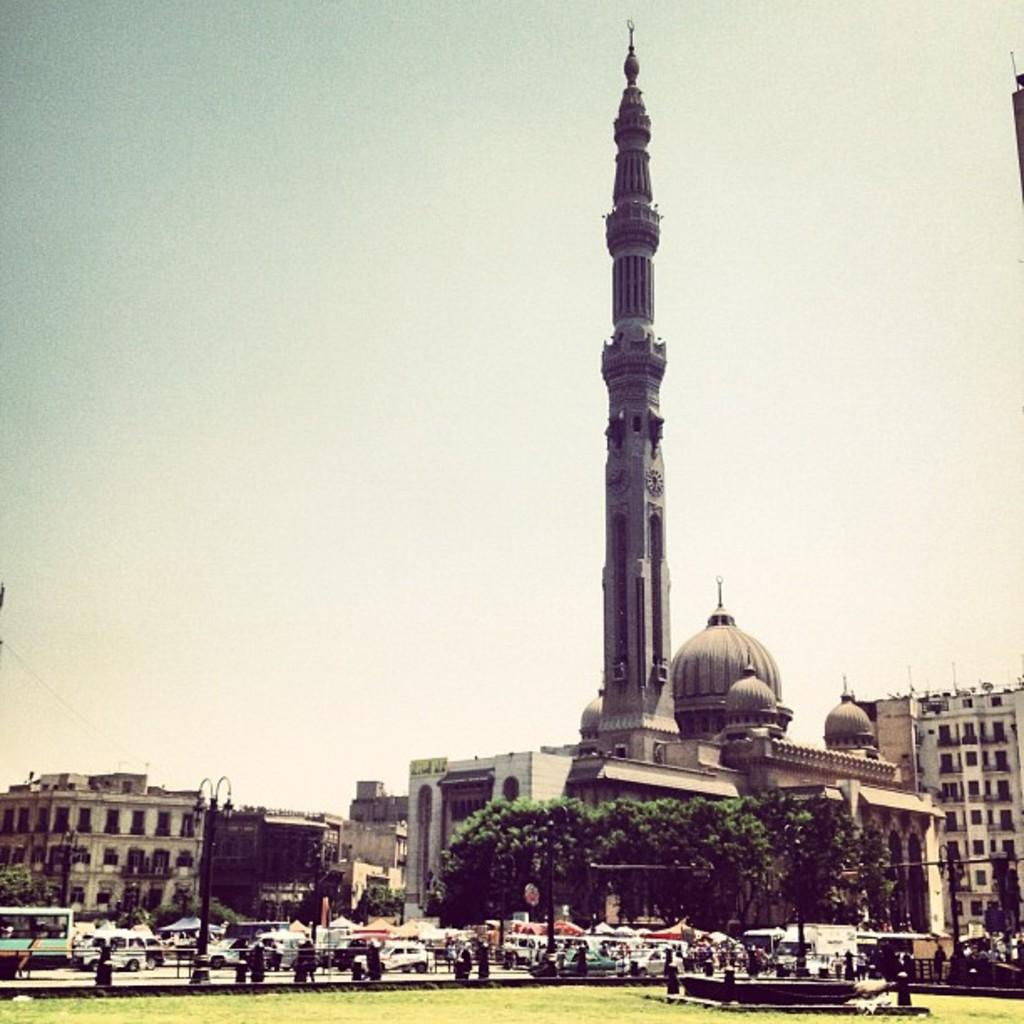What type of surface is visible on the ground in the image? There is grass on the ground in the image. What can be seen in the distance behind the grass? There are vehicles, streetlights, and buildings in the background of the image. What type of wood is being used to plough the grass in the image? There is no wood or plough present in the image; it features grass on the ground and various background elements. 